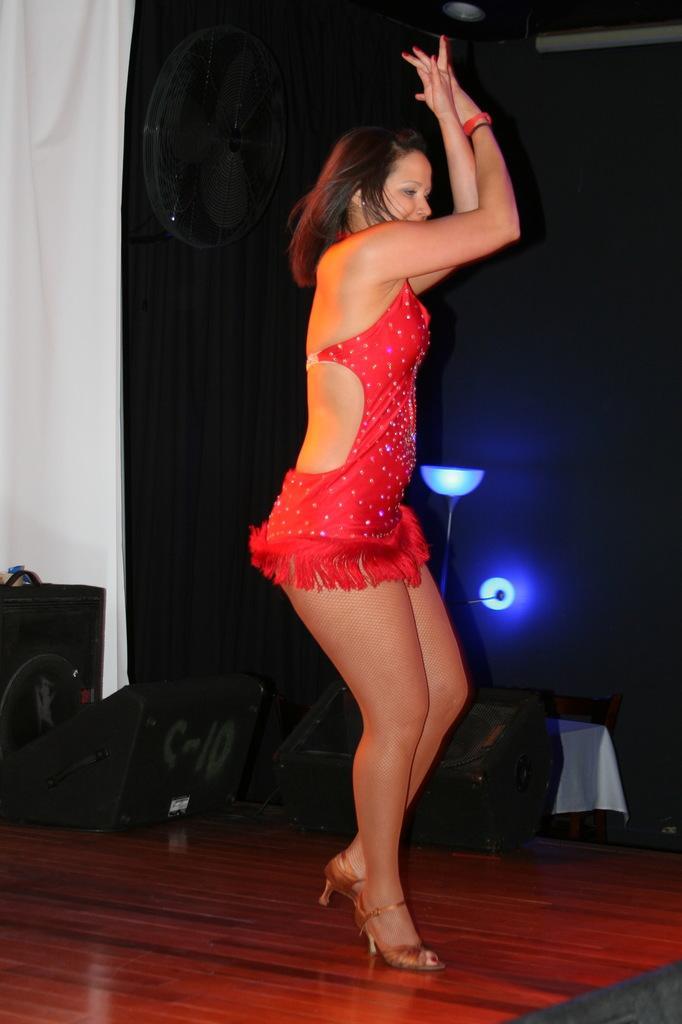How would you summarize this image in a sentence or two? In this picture we can see a woman on the floor. In the background we can see clothes, lights and some objects. 